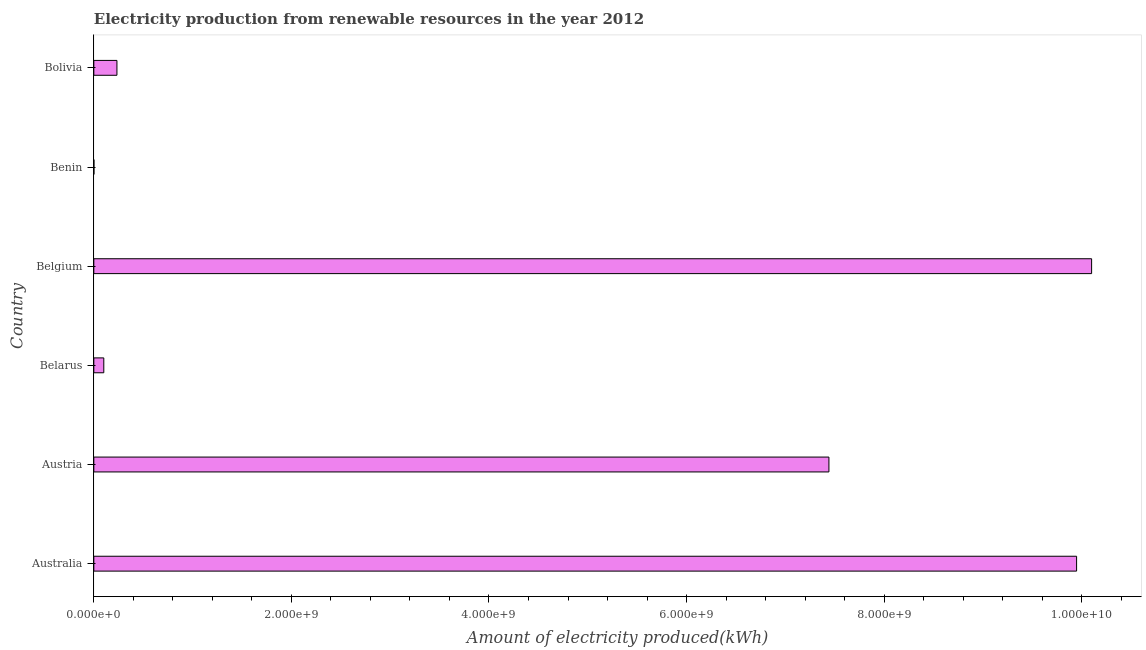Does the graph contain grids?
Give a very brief answer. No. What is the title of the graph?
Your response must be concise. Electricity production from renewable resources in the year 2012. What is the label or title of the X-axis?
Make the answer very short. Amount of electricity produced(kWh). What is the label or title of the Y-axis?
Your answer should be compact. Country. What is the amount of electricity produced in Austria?
Provide a succinct answer. 7.44e+09. Across all countries, what is the maximum amount of electricity produced?
Your response must be concise. 1.01e+1. In which country was the amount of electricity produced maximum?
Offer a terse response. Belgium. In which country was the amount of electricity produced minimum?
Offer a very short reply. Benin. What is the sum of the amount of electricity produced?
Make the answer very short. 2.78e+1. What is the difference between the amount of electricity produced in Australia and Belgium?
Make the answer very short. -1.52e+08. What is the average amount of electricity produced per country?
Give a very brief answer. 4.64e+09. What is the median amount of electricity produced?
Provide a succinct answer. 3.84e+09. In how many countries, is the amount of electricity produced greater than 7600000000 kWh?
Give a very brief answer. 2. What is the ratio of the amount of electricity produced in Benin to that in Bolivia?
Your answer should be compact. 0. Is the amount of electricity produced in Austria less than that in Belgium?
Your answer should be very brief. Yes. Is the difference between the amount of electricity produced in Benin and Bolivia greater than the difference between any two countries?
Your answer should be very brief. No. What is the difference between the highest and the second highest amount of electricity produced?
Make the answer very short. 1.52e+08. What is the difference between the highest and the lowest amount of electricity produced?
Your response must be concise. 1.01e+1. How many bars are there?
Offer a terse response. 6. What is the difference between two consecutive major ticks on the X-axis?
Offer a very short reply. 2.00e+09. Are the values on the major ticks of X-axis written in scientific E-notation?
Offer a terse response. Yes. What is the Amount of electricity produced(kWh) of Australia?
Your answer should be compact. 9.95e+09. What is the Amount of electricity produced(kWh) of Austria?
Give a very brief answer. 7.44e+09. What is the Amount of electricity produced(kWh) in Belarus?
Provide a succinct answer. 1.01e+08. What is the Amount of electricity produced(kWh) in Belgium?
Offer a very short reply. 1.01e+1. What is the Amount of electricity produced(kWh) in Bolivia?
Provide a succinct answer. 2.34e+08. What is the difference between the Amount of electricity produced(kWh) in Australia and Austria?
Keep it short and to the point. 2.51e+09. What is the difference between the Amount of electricity produced(kWh) in Australia and Belarus?
Your response must be concise. 9.85e+09. What is the difference between the Amount of electricity produced(kWh) in Australia and Belgium?
Make the answer very short. -1.52e+08. What is the difference between the Amount of electricity produced(kWh) in Australia and Benin?
Your answer should be very brief. 9.95e+09. What is the difference between the Amount of electricity produced(kWh) in Australia and Bolivia?
Your answer should be very brief. 9.71e+09. What is the difference between the Amount of electricity produced(kWh) in Austria and Belarus?
Give a very brief answer. 7.34e+09. What is the difference between the Amount of electricity produced(kWh) in Austria and Belgium?
Offer a very short reply. -2.66e+09. What is the difference between the Amount of electricity produced(kWh) in Austria and Benin?
Your answer should be compact. 7.44e+09. What is the difference between the Amount of electricity produced(kWh) in Austria and Bolivia?
Offer a terse response. 7.21e+09. What is the difference between the Amount of electricity produced(kWh) in Belarus and Belgium?
Provide a short and direct response. -1.00e+1. What is the difference between the Amount of electricity produced(kWh) in Belarus and Benin?
Make the answer very short. 1.00e+08. What is the difference between the Amount of electricity produced(kWh) in Belarus and Bolivia?
Provide a succinct answer. -1.33e+08. What is the difference between the Amount of electricity produced(kWh) in Belgium and Benin?
Ensure brevity in your answer.  1.01e+1. What is the difference between the Amount of electricity produced(kWh) in Belgium and Bolivia?
Give a very brief answer. 9.87e+09. What is the difference between the Amount of electricity produced(kWh) in Benin and Bolivia?
Provide a short and direct response. -2.33e+08. What is the ratio of the Amount of electricity produced(kWh) in Australia to that in Austria?
Offer a terse response. 1.34. What is the ratio of the Amount of electricity produced(kWh) in Australia to that in Belarus?
Offer a very short reply. 98.5. What is the ratio of the Amount of electricity produced(kWh) in Australia to that in Benin?
Your response must be concise. 9948. What is the ratio of the Amount of electricity produced(kWh) in Australia to that in Bolivia?
Offer a very short reply. 42.51. What is the ratio of the Amount of electricity produced(kWh) in Austria to that in Belarus?
Give a very brief answer. 73.67. What is the ratio of the Amount of electricity produced(kWh) in Austria to that in Belgium?
Offer a terse response. 0.74. What is the ratio of the Amount of electricity produced(kWh) in Austria to that in Benin?
Your answer should be compact. 7441. What is the ratio of the Amount of electricity produced(kWh) in Austria to that in Bolivia?
Your response must be concise. 31.8. What is the ratio of the Amount of electricity produced(kWh) in Belarus to that in Benin?
Your answer should be compact. 101. What is the ratio of the Amount of electricity produced(kWh) in Belarus to that in Bolivia?
Offer a very short reply. 0.43. What is the ratio of the Amount of electricity produced(kWh) in Belgium to that in Benin?
Provide a short and direct response. 1.01e+04. What is the ratio of the Amount of electricity produced(kWh) in Belgium to that in Bolivia?
Make the answer very short. 43.16. What is the ratio of the Amount of electricity produced(kWh) in Benin to that in Bolivia?
Your answer should be very brief. 0. 